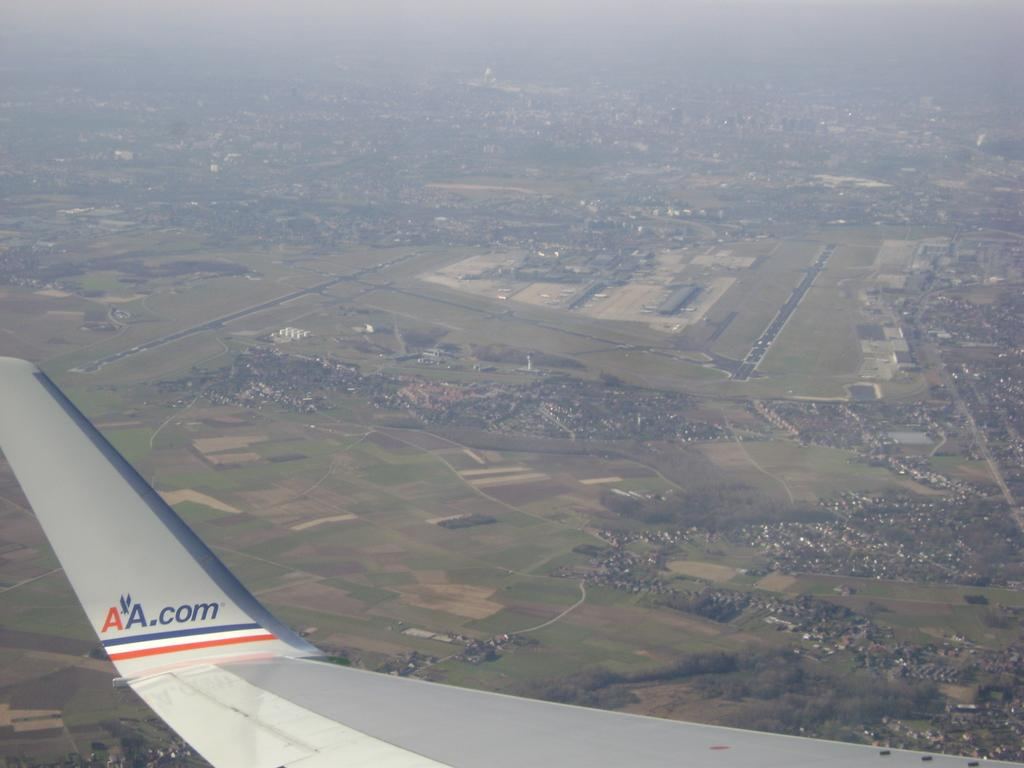What type of view is shown in the image? The image is an aerial view. What part of an airplane can be seen in the image? There is an airplane wing at the bottom side of the image. What type of income can be seen in the image? There is no income visible in the image; it is an aerial view of an airplane wing. What type of prose is being written in the image? There is no writing or prose present in the image; it is an aerial view of an airplane wing. 